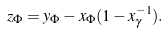Convert formula to latex. <formula><loc_0><loc_0><loc_500><loc_500>z _ { \Phi } = y _ { \Phi } - x _ { \Phi } ( 1 - x _ { \gamma } ^ { - 1 } ) .</formula> 